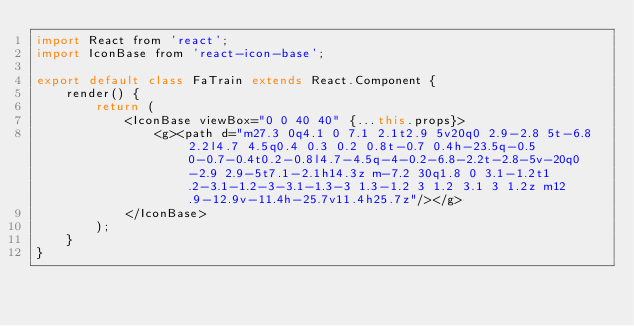Convert code to text. <code><loc_0><loc_0><loc_500><loc_500><_JavaScript_>import React from 'react';
import IconBase from 'react-icon-base';

export default class FaTrain extends React.Component {
    render() {
        return (
            <IconBase viewBox="0 0 40 40" {...this.props}>
                <g><path d="m27.3 0q4.1 0 7.1 2.1t2.9 5v20q0 2.9-2.8 5t-6.8 2.2l4.7 4.5q0.4 0.3 0.2 0.8t-0.7 0.4h-23.5q-0.5 0-0.7-0.4t0.2-0.8l4.7-4.5q-4-0.2-6.8-2.2t-2.8-5v-20q0-2.9 2.9-5t7.1-2.1h14.3z m-7.2 30q1.8 0 3.1-1.2t1.2-3.1-1.2-3-3.1-1.3-3 1.3-1.2 3 1.2 3.1 3 1.2z m12.9-12.9v-11.4h-25.7v11.4h25.7z"/></g>
            </IconBase>
        );
    }
}
</code> 